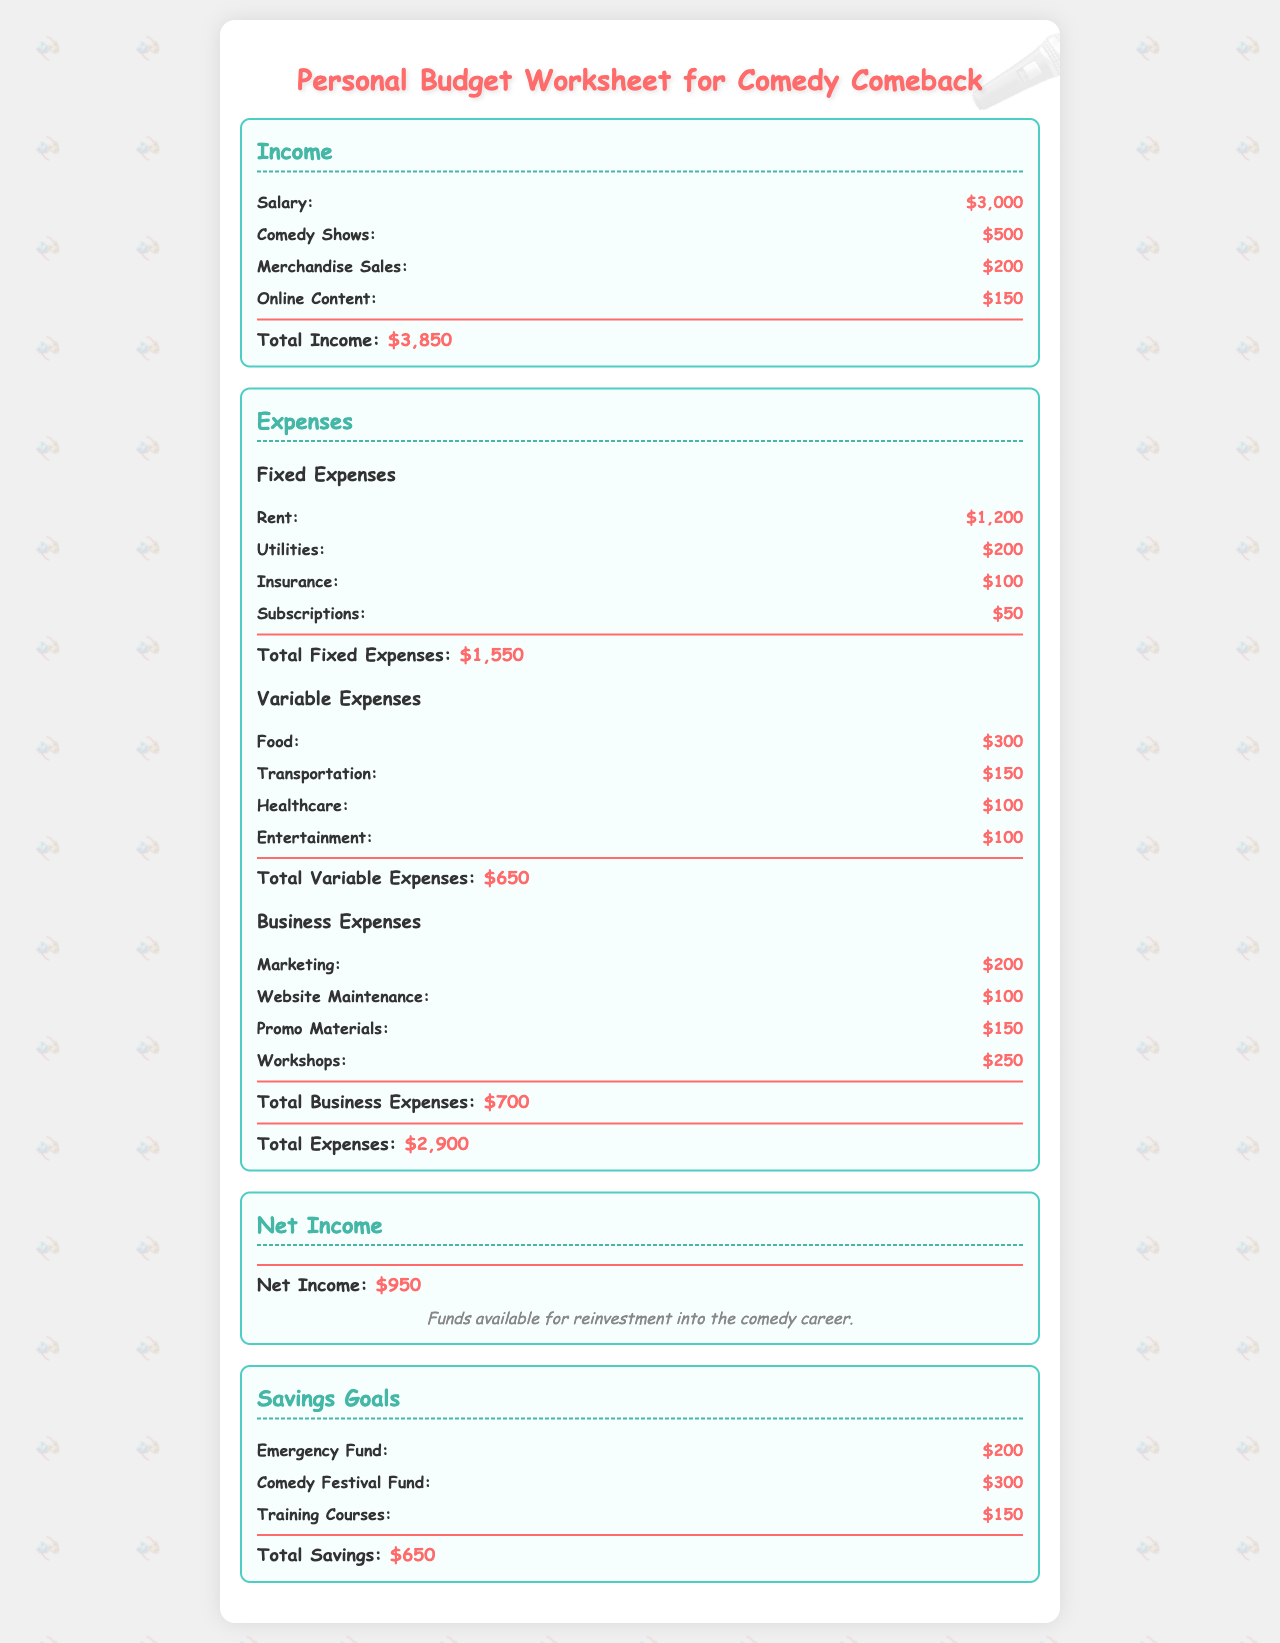what is the total income? The total income is the sum of all income sources in the document, including salary, comedy shows, merchandise sales, and online content, which adds up to $3,850.
Answer: $3,850 what is the total fixed expenses? The total fixed expenses are derived from the sum of rent, utilities, insurance, and subscriptions, totaling $1,550.
Answer: $1,550 how much is allocated for marketing? The marketing expense specifically listed under business expenses amounts to $200 in the document.
Answer: $200 what is the net income? The net income is calculated by subtracting total expenses from total income, resulting in $950.
Answer: $950 what is the total variable expenses? The total variable expenses are the sum of food, transportation, healthcare, and entertainment, which comes to $650.
Answer: $650 how much is the comedy festival fund in savings goals? The comedy festival fund is specifically listed as $300 under the savings goals section.
Answer: $300 what are the total business expenses? The total business expenses are the sum of marketing, website maintenance, promo materials, and workshops, amounting to $700.
Answer: $700 what is the total savings? The total savings are calculated by summing the emergency fund, comedy festival fund, and training courses, totaling $650.
Answer: $650 how much is allocated for workshops? The workshops expense listed under business expenses amounts to $250 in the document.
Answer: $250 